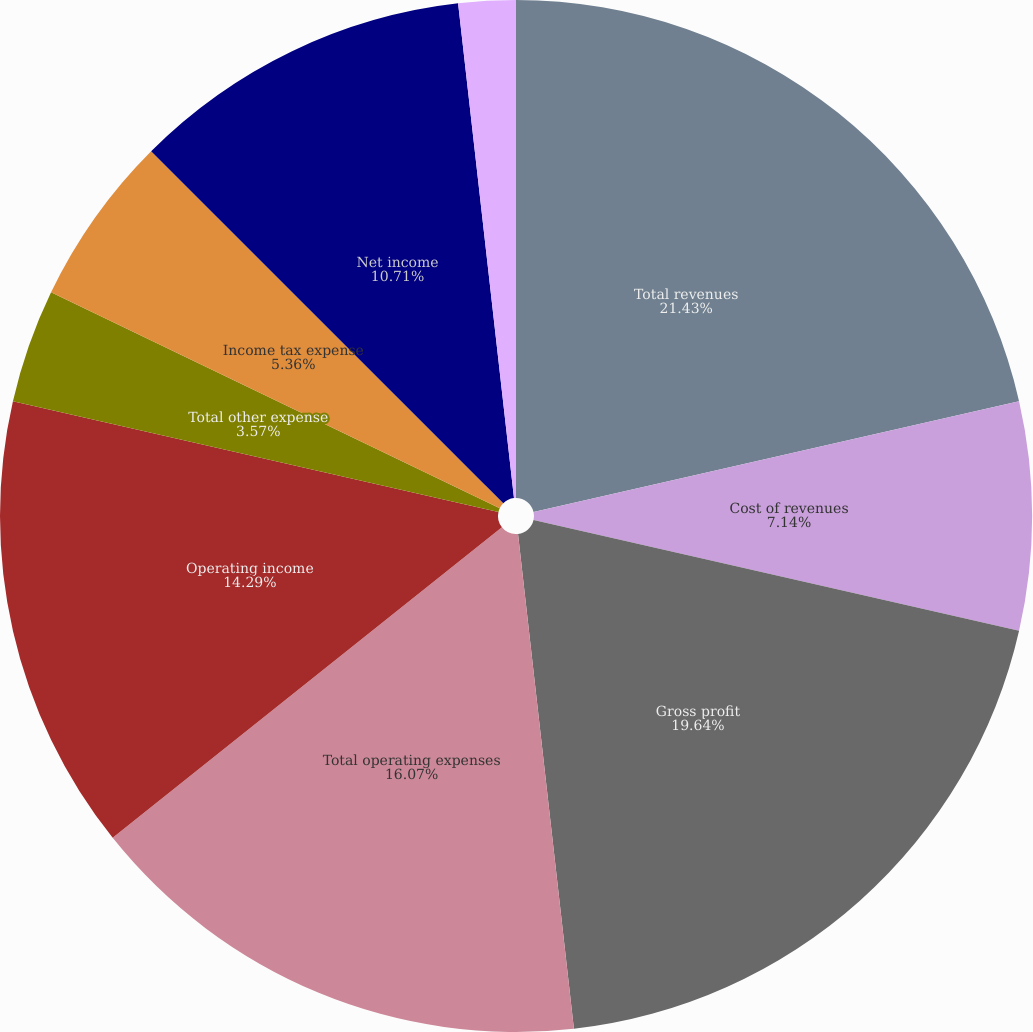Convert chart to OTSL. <chart><loc_0><loc_0><loc_500><loc_500><pie_chart><fcel>Total revenues<fcel>Cost of revenues<fcel>Gross profit<fcel>Total operating expenses<fcel>Operating income<fcel>Total other expense<fcel>Income tax expense<fcel>Net income<fcel>Net income applicable to<nl><fcel>21.43%<fcel>7.14%<fcel>19.64%<fcel>16.07%<fcel>14.29%<fcel>3.57%<fcel>5.36%<fcel>10.71%<fcel>1.79%<nl></chart> 